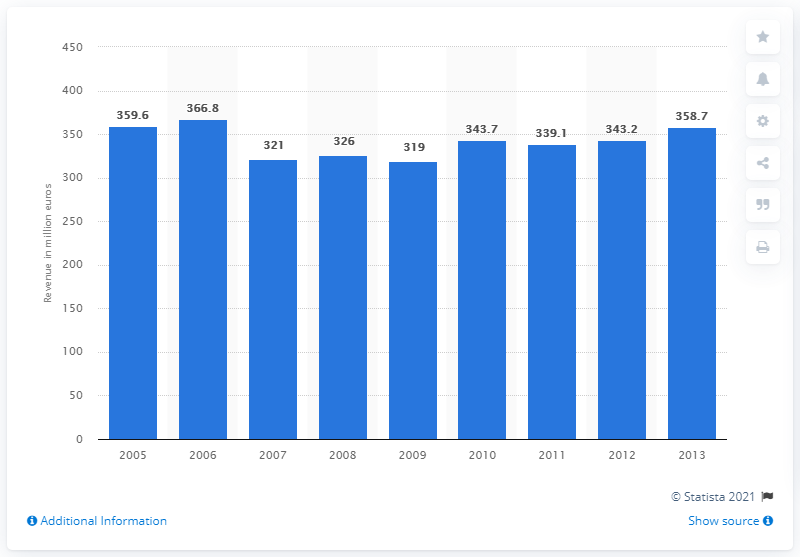Can you describe what this image shows? The image presents a bar chart depicting the annual revenue in millions of euros for an entity over a period from 2005 to 2013. The bars represent revenue figures for each year, allowing us to analyze the trends over time.  What trend do you observe in the company's financial performance from 2005 to 2013 based on this chart? From the chart, we can observe that the company experienced its highest reported revenue in 2006 with 366.8 million euros. This was followed by a decline until 2009, and from there, a somewhat fluctuating but generally stable revenue stream from 2010 to 2013. 